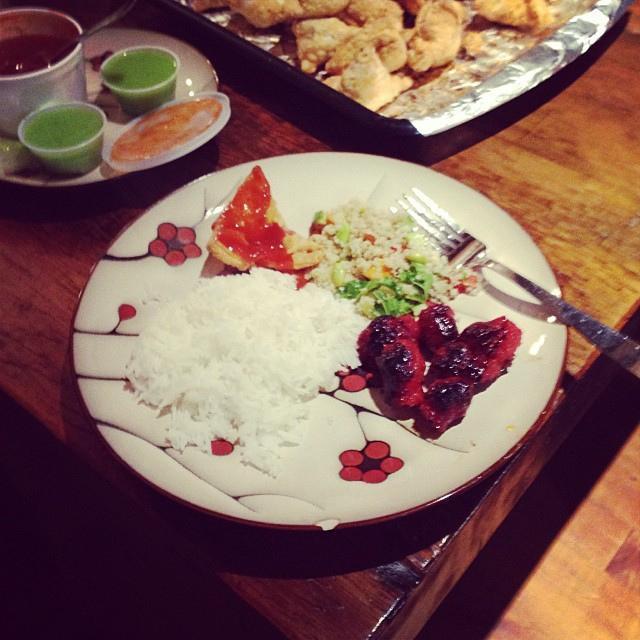How many bowls are in the picture?
Give a very brief answer. 3. 